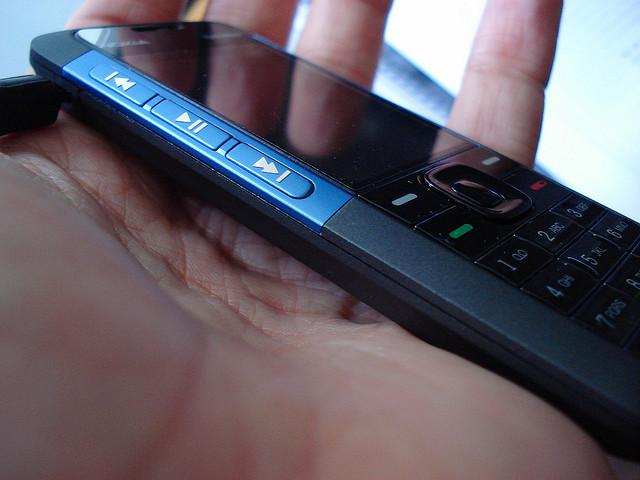What do the buttons that are closest to the observer do?
Be succinct. Fast forward. What can you do with this device?
Give a very brief answer. Call. What is the man holding in his hand?
Keep it brief. Phone. Is this a phone?
Quick response, please. Yes. 